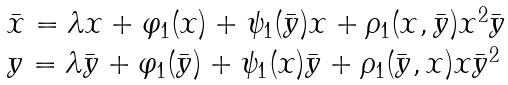<formula> <loc_0><loc_0><loc_500><loc_500>\begin{array} { l } \bar { x } = \lambda x + \varphi _ { 1 } ( x ) + \psi _ { 1 } ( \bar { y } ) x + \rho _ { 1 } ( x , \bar { y } ) x ^ { 2 } \bar { y } \\ y = \lambda \bar { y } + \varphi _ { 1 } ( \bar { y } ) + \psi _ { 1 } ( x ) \bar { y } + \rho _ { 1 } ( \bar { y } , x ) x \bar { y } ^ { 2 } \end{array}</formula> 